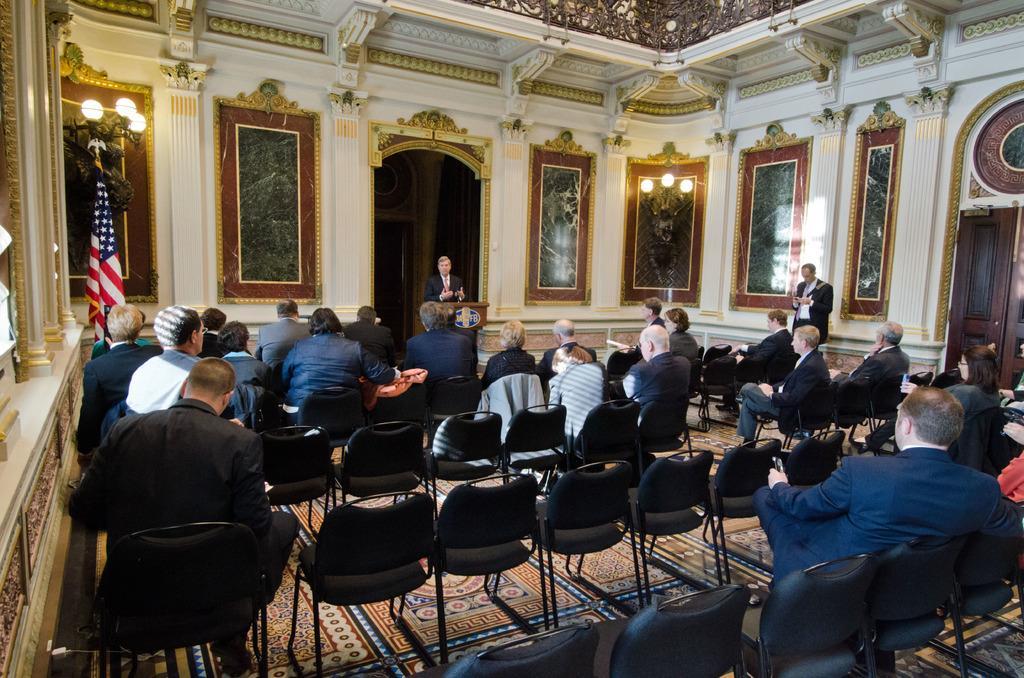Please provide a concise description of this image. In this image i can see a group of people sitting on chair at the back ground i can see the other person standing in front of the podium at left there is a flag, a frame attached to a wall and a light. 